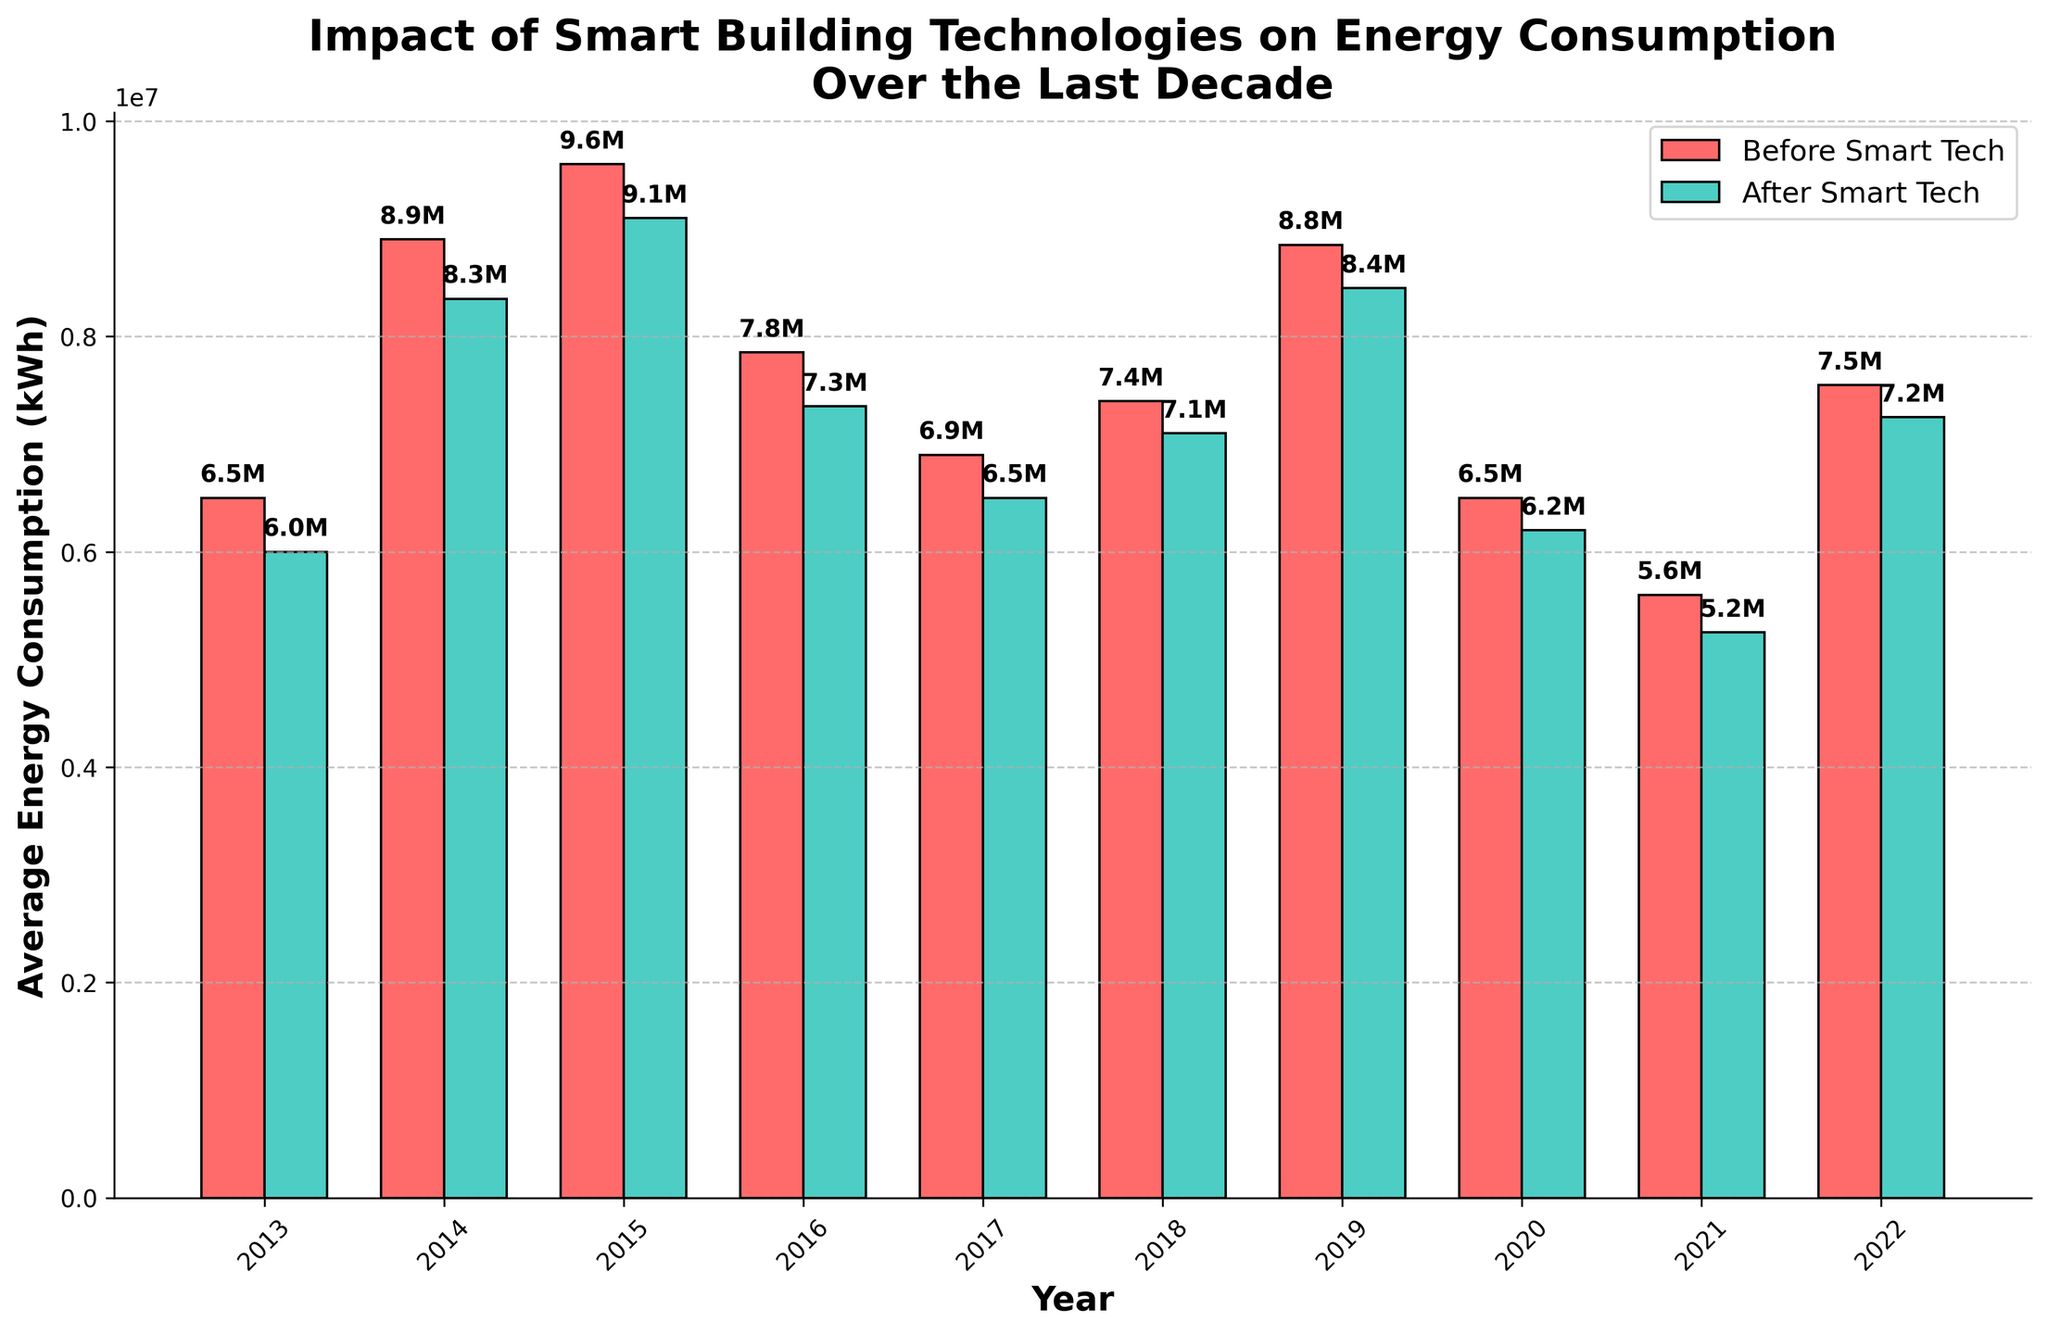Which year experienced the largest reduction in average energy consumption after implementing smart building technologies? Identify the year with the highest difference between before and after average energy consumption bars. In this case, 2014 shows the largest difference.
Answer: 2014 What is the title of the figure? Read the title of the figure, located at the top center.
Answer: Impact of Smart Building Technologies on Energy Consumption Over the Last Decade How many years are covered in this figure? Count the number of x-ticks (years) on the x-axis. There are 10 years displayed from 2013 to 2022.
Answer: 10 What is the average energy consumption before smart tech in 2020? Find the bar corresponding to 2020 on the x-axis, before smart tech (red bar). The value displayed is 7,800,000 kWh or 7.8M.
Answer: 7.8M How much did the average energy consumption decrease in 2015 after implementing smart technologies? Identify the difference between the two bars for 2015. Before (red) is 10M and after (green) is 9.5M. So, the decrease is 0.5M.
Answer: 0.5M Which year had the lowest average energy consumption after implementing smart technologies? Look at the green bars (after smart tech) and find the lowest one. It's in 2021, with a value of 4.7M.
Answer: 2021 How does the trend of average energy consumption before smart technologies compare over the years? Observe the red bars over the years to describe the general trend. The trend shows an initial peak followed by a gradual decline.
Answer: Initial peak, gradual decline What is the range of the average energy consumption after smart technologies in 2017? Identify the green bar corresponding to 2017 and note its value. The range post-smart tech for 2017 is between the min (8.1M) and max (8.6M).
Answer: 8.1M to 8.6M In which year is the difference between energy consumption before and after smart tech the smallest? Identify the pair where the two bars are closest together. For 2020, the difference is quite minimal.
Answer: 2020 Considering the overall trend, does the implementation of smart building technologies consistently reduce energy consumption across the decade? Review the differences between corresponding bar pairs throughout the years and note that energy consumption is consistently lower post-implementation.
Answer: Yes, consistently lower 